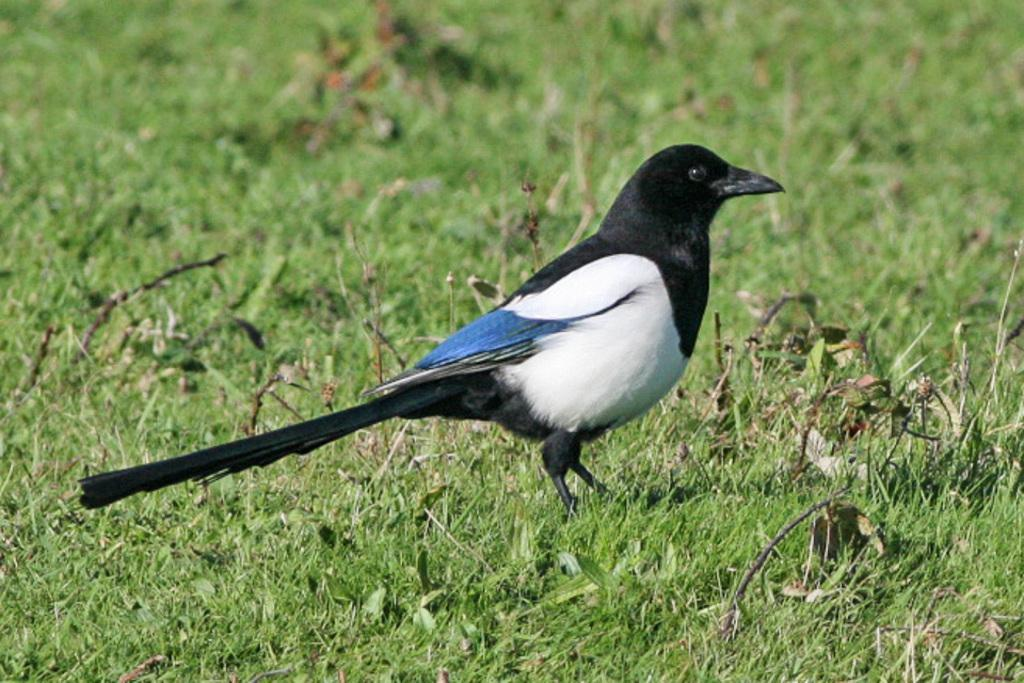What type of animal can be seen in the image? There is a bird in the image. Where is the bird located? The bird is standing on grassland. What else can be seen on the grassland? There are plants on the grassland. How can the bird be described in terms of its appearance? The bird has different colors. What is the temperature of the bird's knee in the image? The image does not provide information about the bird's knee or its temperature, as it only shows the bird standing on grassland. 